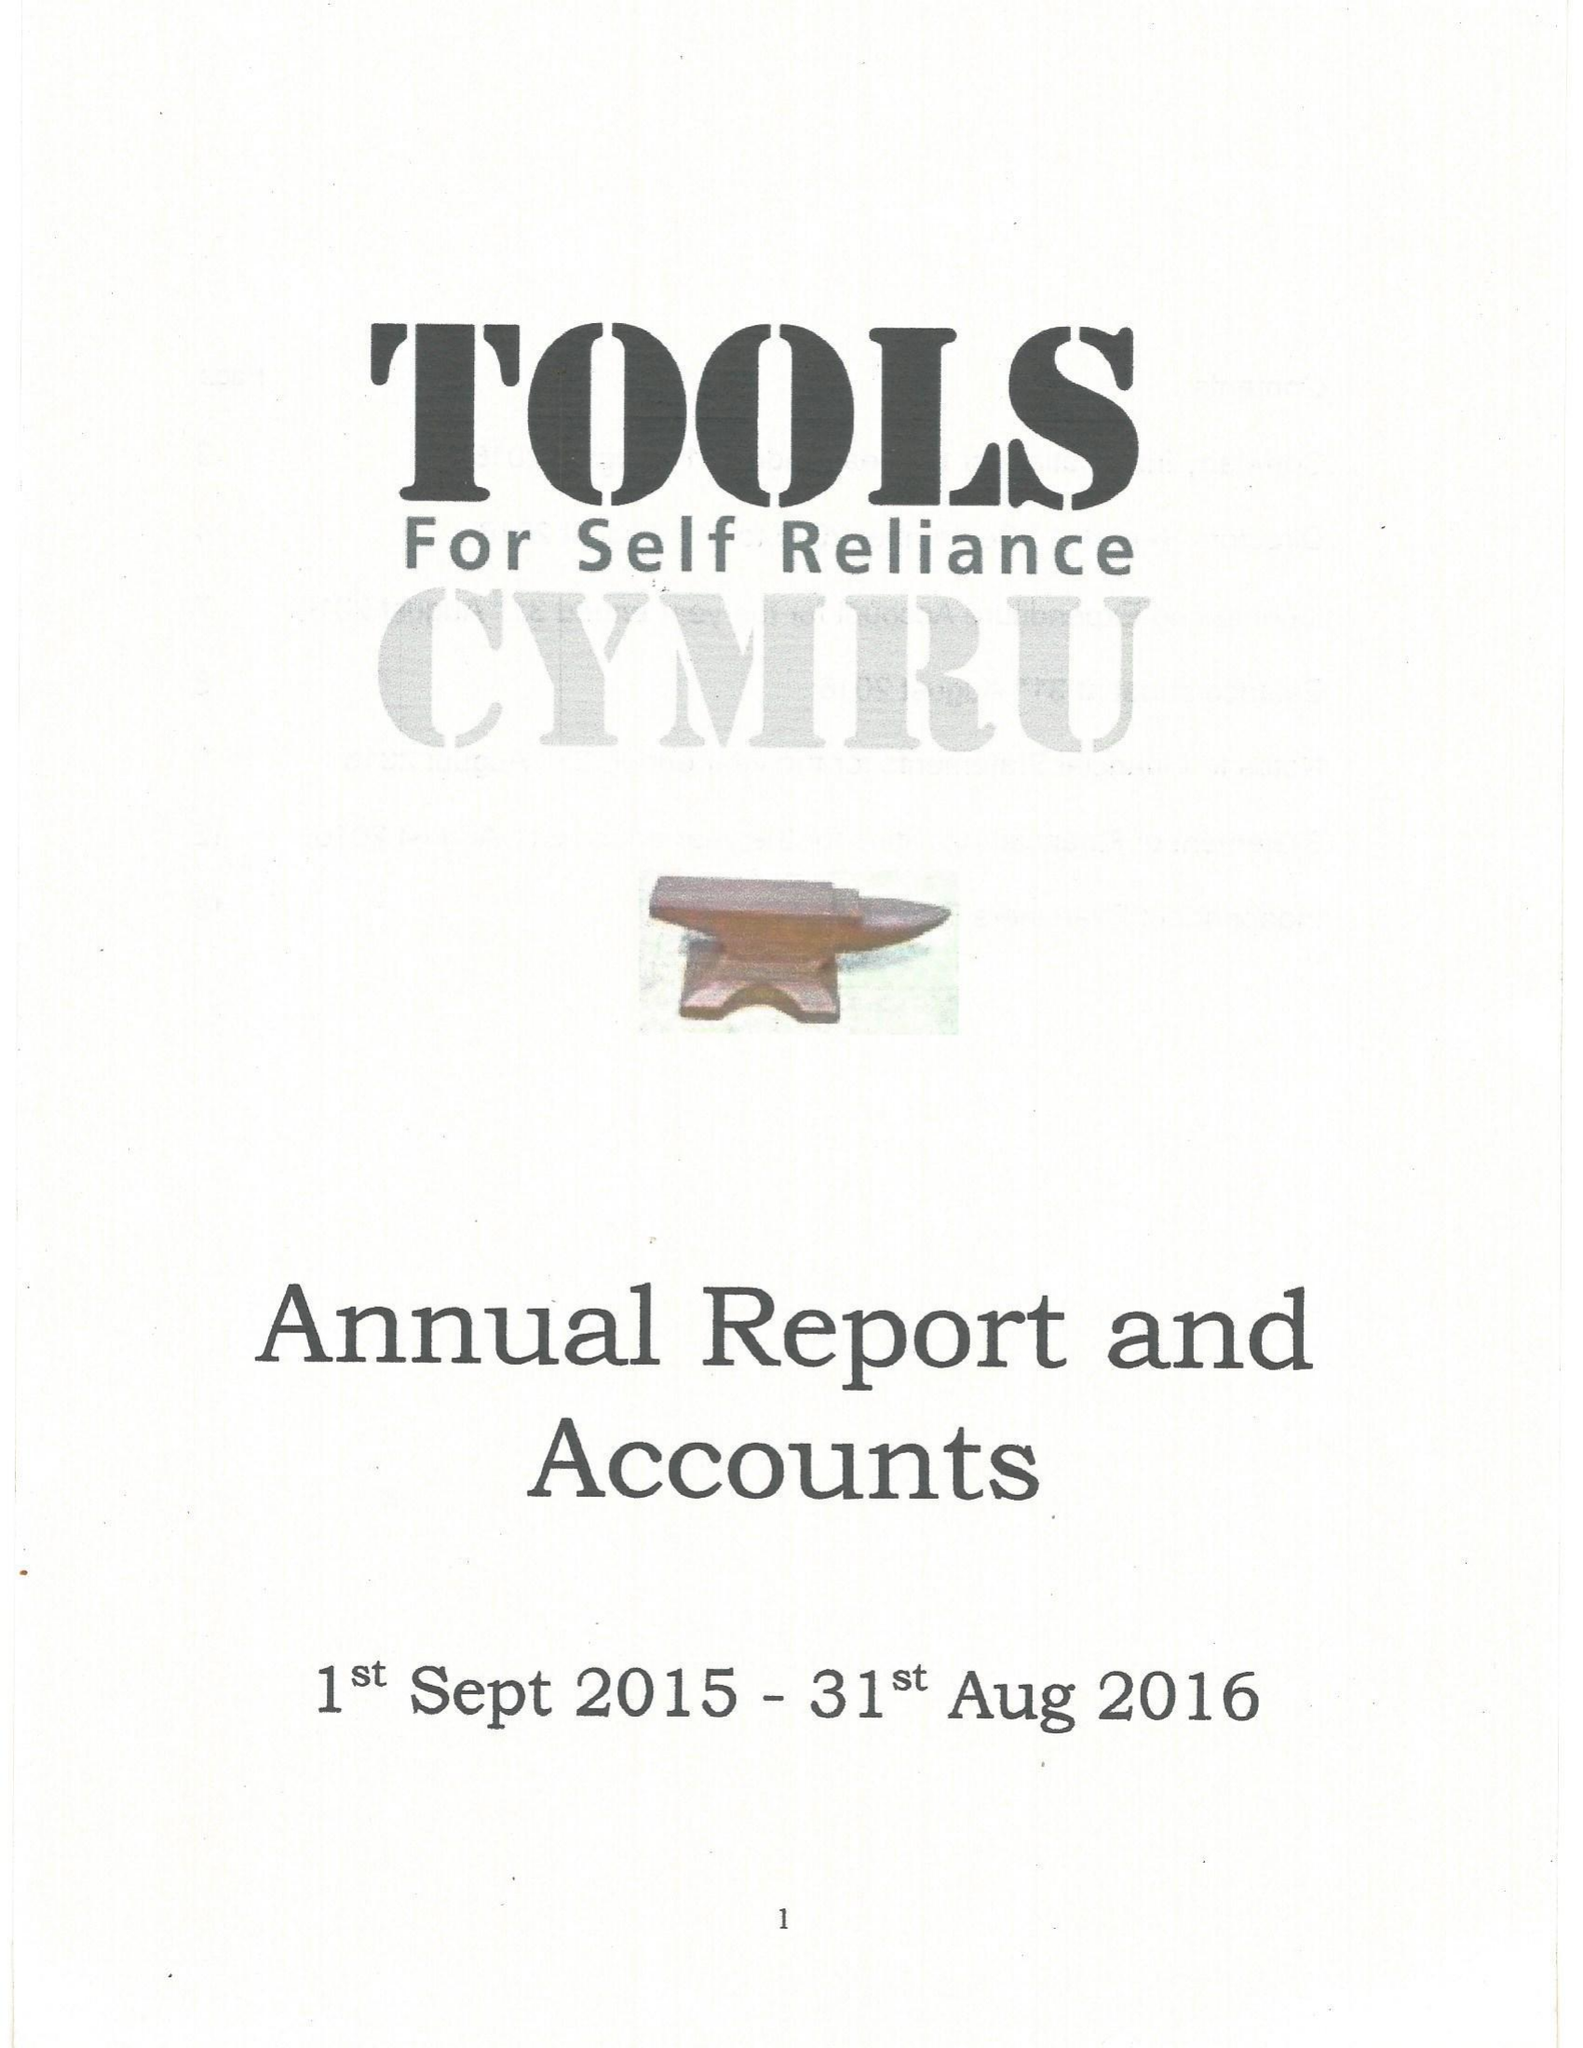What is the value for the address__post_town?
Answer the question using a single word or phrase. None 